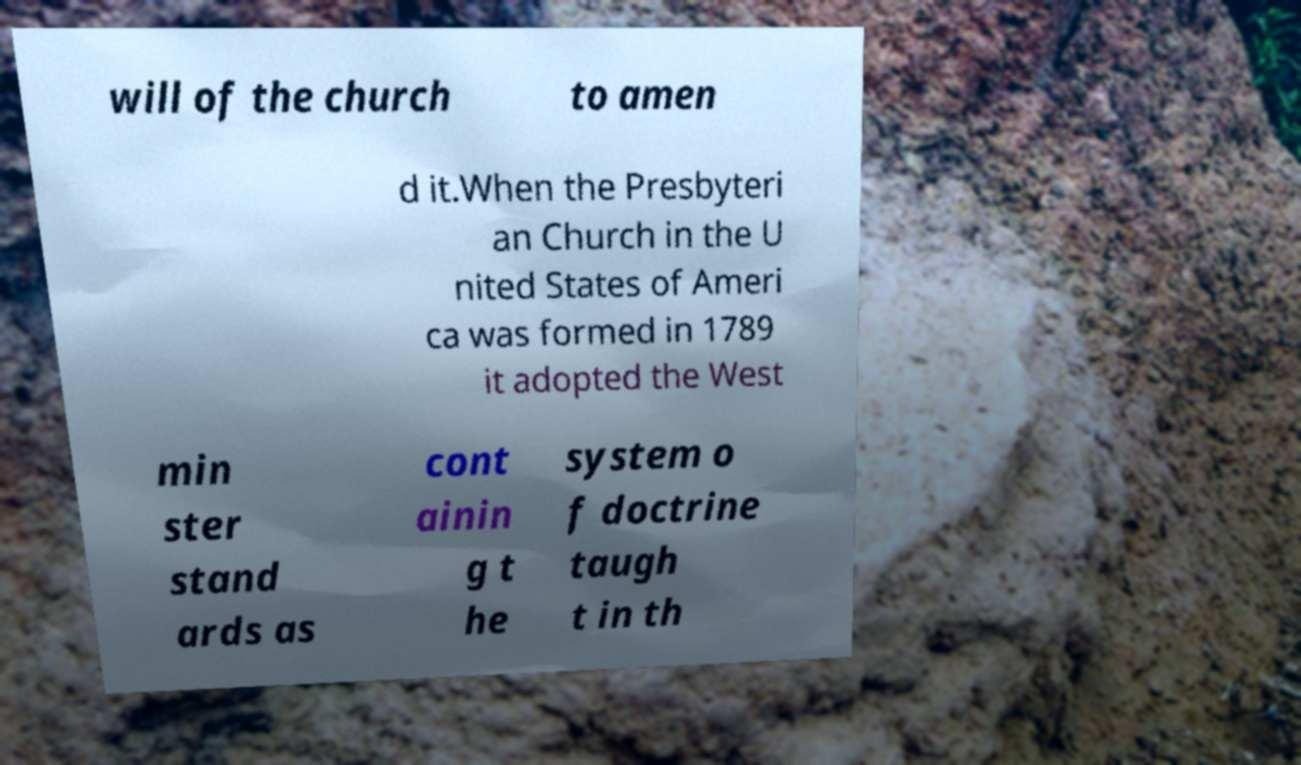I need the written content from this picture converted into text. Can you do that? will of the church to amen d it.When the Presbyteri an Church in the U nited States of Ameri ca was formed in 1789 it adopted the West min ster stand ards as cont ainin g t he system o f doctrine taugh t in th 